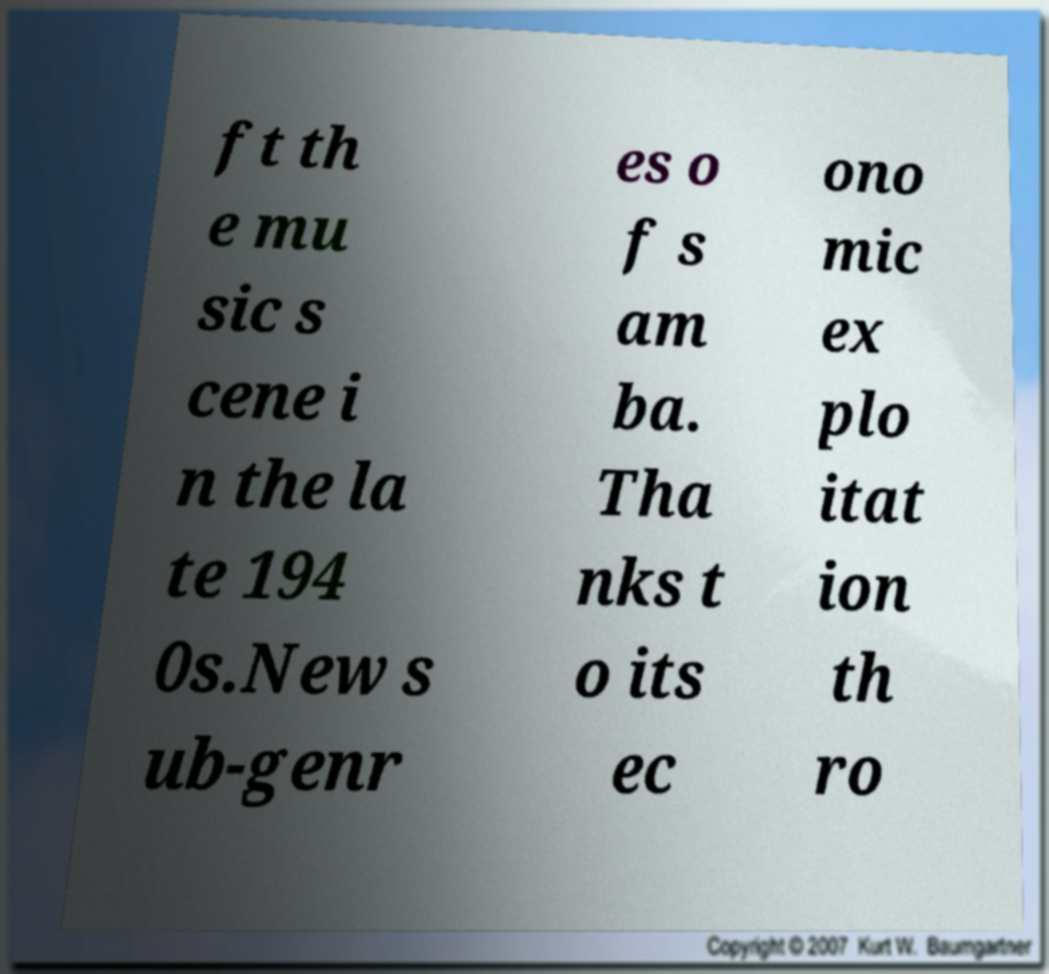For documentation purposes, I need the text within this image transcribed. Could you provide that? ft th e mu sic s cene i n the la te 194 0s.New s ub-genr es o f s am ba. Tha nks t o its ec ono mic ex plo itat ion th ro 